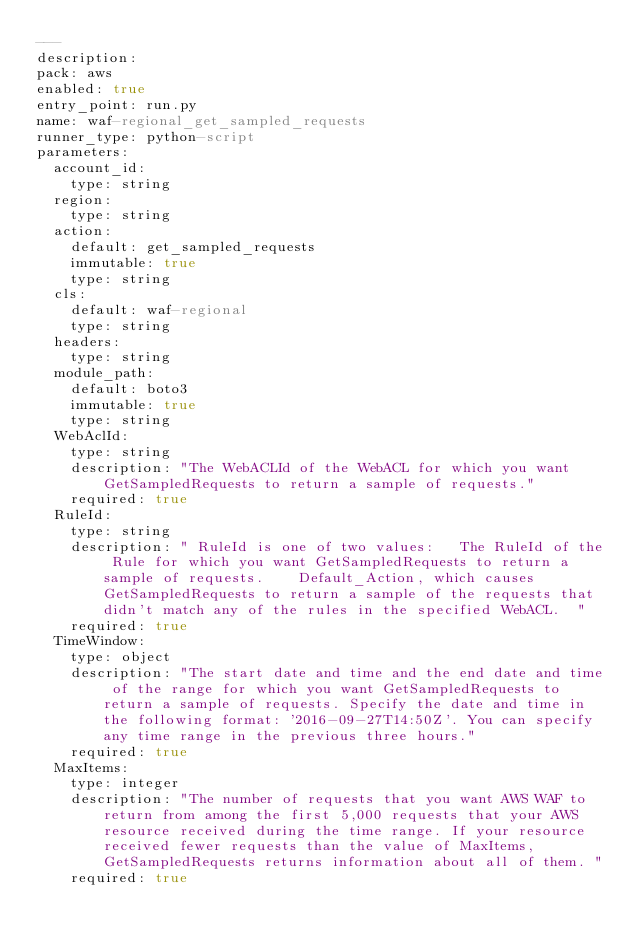Convert code to text. <code><loc_0><loc_0><loc_500><loc_500><_YAML_>---
description: 
pack: aws
enabled: true
entry_point: run.py
name: waf-regional_get_sampled_requests
runner_type: python-script
parameters:
  account_id:
    type: string
  region:
    type: string
  action:
    default: get_sampled_requests
    immutable: true
    type: string
  cls:
    default: waf-regional
    type: string
  headers:
    type: string
  module_path:
    default: boto3
    immutable: true
    type: string
  WebAclId:
    type: string
    description: "The WebACLId of the WebACL for which you want GetSampledRequests to return a sample of requests."
    required: true
  RuleId:
    type: string
    description: " RuleId is one of two values:   The RuleId of the Rule for which you want GetSampledRequests to return a sample of requests.    Default_Action, which causes GetSampledRequests to return a sample of the requests that didn't match any of the rules in the specified WebACL.  "
    required: true
  TimeWindow:
    type: object
    description: "The start date and time and the end date and time of the range for which you want GetSampledRequests to return a sample of requests. Specify the date and time in the following format: '2016-09-27T14:50Z'. You can specify any time range in the previous three hours."
    required: true
  MaxItems:
    type: integer
    description: "The number of requests that you want AWS WAF to return from among the first 5,000 requests that your AWS resource received during the time range. If your resource received fewer requests than the value of MaxItems, GetSampledRequests returns information about all of them. "
    required: true</code> 